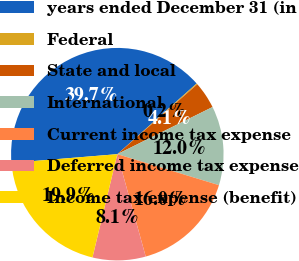Convert chart. <chart><loc_0><loc_0><loc_500><loc_500><pie_chart><fcel>years ended December 31 (in<fcel>Federal<fcel>State and local<fcel>International<fcel>Current income tax expense<fcel>Deferred income tax expense<fcel>Income tax expense (benefit)<nl><fcel>39.72%<fcel>0.16%<fcel>4.11%<fcel>12.03%<fcel>15.98%<fcel>8.07%<fcel>19.94%<nl></chart> 